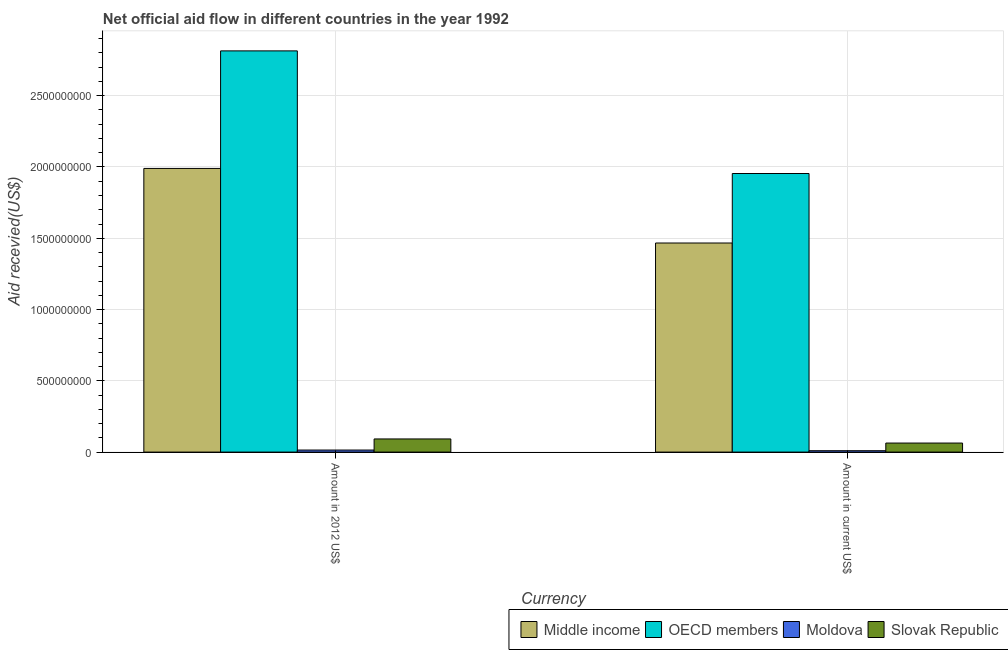Are the number of bars on each tick of the X-axis equal?
Offer a very short reply. Yes. How many bars are there on the 2nd tick from the right?
Provide a short and direct response. 4. What is the label of the 2nd group of bars from the left?
Provide a short and direct response. Amount in current US$. What is the amount of aid received(expressed in 2012 us$) in Middle income?
Make the answer very short. 1.99e+09. Across all countries, what is the maximum amount of aid received(expressed in 2012 us$)?
Provide a succinct answer. 2.81e+09. Across all countries, what is the minimum amount of aid received(expressed in us$)?
Provide a succinct answer. 9.70e+06. In which country was the amount of aid received(expressed in us$) maximum?
Your answer should be compact. OECD members. In which country was the amount of aid received(expressed in us$) minimum?
Give a very brief answer. Moldova. What is the total amount of aid received(expressed in us$) in the graph?
Your answer should be very brief. 3.49e+09. What is the difference between the amount of aid received(expressed in 2012 us$) in Middle income and that in Slovak Republic?
Provide a short and direct response. 1.90e+09. What is the difference between the amount of aid received(expressed in us$) in Slovak Republic and the amount of aid received(expressed in 2012 us$) in Middle income?
Offer a terse response. -1.93e+09. What is the average amount of aid received(expressed in 2012 us$) per country?
Offer a terse response. 1.23e+09. What is the difference between the amount of aid received(expressed in us$) and amount of aid received(expressed in 2012 us$) in Moldova?
Ensure brevity in your answer.  -4.72e+06. In how many countries, is the amount of aid received(expressed in 2012 us$) greater than 2600000000 US$?
Keep it short and to the point. 1. What is the ratio of the amount of aid received(expressed in 2012 us$) in Slovak Republic to that in Moldova?
Offer a very short reply. 6.4. Is the amount of aid received(expressed in us$) in OECD members less than that in Moldova?
Provide a succinct answer. No. What does the 2nd bar from the right in Amount in 2012 US$ represents?
Ensure brevity in your answer.  Moldova. How many bars are there?
Provide a short and direct response. 8. Are all the bars in the graph horizontal?
Your answer should be very brief. No. Are the values on the major ticks of Y-axis written in scientific E-notation?
Offer a terse response. No. Does the graph contain any zero values?
Your answer should be very brief. No. Does the graph contain grids?
Keep it short and to the point. Yes. Where does the legend appear in the graph?
Offer a terse response. Bottom right. How many legend labels are there?
Your answer should be compact. 4. What is the title of the graph?
Ensure brevity in your answer.  Net official aid flow in different countries in the year 1992. What is the label or title of the X-axis?
Provide a short and direct response. Currency. What is the label or title of the Y-axis?
Provide a short and direct response. Aid recevied(US$). What is the Aid recevied(US$) in Middle income in Amount in 2012 US$?
Offer a very short reply. 1.99e+09. What is the Aid recevied(US$) of OECD members in Amount in 2012 US$?
Your response must be concise. 2.81e+09. What is the Aid recevied(US$) of Moldova in Amount in 2012 US$?
Keep it short and to the point. 1.44e+07. What is the Aid recevied(US$) in Slovak Republic in Amount in 2012 US$?
Offer a terse response. 9.22e+07. What is the Aid recevied(US$) of Middle income in Amount in current US$?
Your response must be concise. 1.47e+09. What is the Aid recevied(US$) in OECD members in Amount in current US$?
Your response must be concise. 1.95e+09. What is the Aid recevied(US$) in Moldova in Amount in current US$?
Make the answer very short. 9.70e+06. What is the Aid recevied(US$) in Slovak Republic in Amount in current US$?
Offer a terse response. 6.34e+07. Across all Currency, what is the maximum Aid recevied(US$) in Middle income?
Give a very brief answer. 1.99e+09. Across all Currency, what is the maximum Aid recevied(US$) in OECD members?
Offer a very short reply. 2.81e+09. Across all Currency, what is the maximum Aid recevied(US$) in Moldova?
Provide a succinct answer. 1.44e+07. Across all Currency, what is the maximum Aid recevied(US$) in Slovak Republic?
Keep it short and to the point. 9.22e+07. Across all Currency, what is the minimum Aid recevied(US$) of Middle income?
Offer a very short reply. 1.47e+09. Across all Currency, what is the minimum Aid recevied(US$) of OECD members?
Provide a succinct answer. 1.95e+09. Across all Currency, what is the minimum Aid recevied(US$) in Moldova?
Provide a short and direct response. 9.70e+06. Across all Currency, what is the minimum Aid recevied(US$) of Slovak Republic?
Provide a succinct answer. 6.34e+07. What is the total Aid recevied(US$) in Middle income in the graph?
Ensure brevity in your answer.  3.46e+09. What is the total Aid recevied(US$) of OECD members in the graph?
Offer a very short reply. 4.77e+09. What is the total Aid recevied(US$) of Moldova in the graph?
Your answer should be compact. 2.41e+07. What is the total Aid recevied(US$) of Slovak Republic in the graph?
Offer a terse response. 1.56e+08. What is the difference between the Aid recevied(US$) in Middle income in Amount in 2012 US$ and that in Amount in current US$?
Offer a terse response. 5.23e+08. What is the difference between the Aid recevied(US$) of OECD members in Amount in 2012 US$ and that in Amount in current US$?
Give a very brief answer. 8.60e+08. What is the difference between the Aid recevied(US$) in Moldova in Amount in 2012 US$ and that in Amount in current US$?
Ensure brevity in your answer.  4.72e+06. What is the difference between the Aid recevied(US$) in Slovak Republic in Amount in 2012 US$ and that in Amount in current US$?
Provide a succinct answer. 2.89e+07. What is the difference between the Aid recevied(US$) of Middle income in Amount in 2012 US$ and the Aid recevied(US$) of OECD members in Amount in current US$?
Offer a very short reply. 3.56e+07. What is the difference between the Aid recevied(US$) of Middle income in Amount in 2012 US$ and the Aid recevied(US$) of Moldova in Amount in current US$?
Ensure brevity in your answer.  1.98e+09. What is the difference between the Aid recevied(US$) in Middle income in Amount in 2012 US$ and the Aid recevied(US$) in Slovak Republic in Amount in current US$?
Your answer should be very brief. 1.93e+09. What is the difference between the Aid recevied(US$) of OECD members in Amount in 2012 US$ and the Aid recevied(US$) of Moldova in Amount in current US$?
Make the answer very short. 2.80e+09. What is the difference between the Aid recevied(US$) in OECD members in Amount in 2012 US$ and the Aid recevied(US$) in Slovak Republic in Amount in current US$?
Provide a succinct answer. 2.75e+09. What is the difference between the Aid recevied(US$) in Moldova in Amount in 2012 US$ and the Aid recevied(US$) in Slovak Republic in Amount in current US$?
Your answer should be very brief. -4.89e+07. What is the average Aid recevied(US$) in Middle income per Currency?
Keep it short and to the point. 1.73e+09. What is the average Aid recevied(US$) of OECD members per Currency?
Provide a succinct answer. 2.38e+09. What is the average Aid recevied(US$) of Moldova per Currency?
Provide a short and direct response. 1.21e+07. What is the average Aid recevied(US$) in Slovak Republic per Currency?
Keep it short and to the point. 7.78e+07. What is the difference between the Aid recevied(US$) in Middle income and Aid recevied(US$) in OECD members in Amount in 2012 US$?
Give a very brief answer. -8.25e+08. What is the difference between the Aid recevied(US$) in Middle income and Aid recevied(US$) in Moldova in Amount in 2012 US$?
Your response must be concise. 1.98e+09. What is the difference between the Aid recevied(US$) in Middle income and Aid recevied(US$) in Slovak Republic in Amount in 2012 US$?
Your answer should be compact. 1.90e+09. What is the difference between the Aid recevied(US$) of OECD members and Aid recevied(US$) of Moldova in Amount in 2012 US$?
Your response must be concise. 2.80e+09. What is the difference between the Aid recevied(US$) of OECD members and Aid recevied(US$) of Slovak Republic in Amount in 2012 US$?
Your response must be concise. 2.72e+09. What is the difference between the Aid recevied(US$) of Moldova and Aid recevied(US$) of Slovak Republic in Amount in 2012 US$?
Make the answer very short. -7.78e+07. What is the difference between the Aid recevied(US$) in Middle income and Aid recevied(US$) in OECD members in Amount in current US$?
Your answer should be very brief. -4.88e+08. What is the difference between the Aid recevied(US$) in Middle income and Aid recevied(US$) in Moldova in Amount in current US$?
Offer a terse response. 1.46e+09. What is the difference between the Aid recevied(US$) of Middle income and Aid recevied(US$) of Slovak Republic in Amount in current US$?
Make the answer very short. 1.40e+09. What is the difference between the Aid recevied(US$) in OECD members and Aid recevied(US$) in Moldova in Amount in current US$?
Give a very brief answer. 1.94e+09. What is the difference between the Aid recevied(US$) in OECD members and Aid recevied(US$) in Slovak Republic in Amount in current US$?
Keep it short and to the point. 1.89e+09. What is the difference between the Aid recevied(US$) in Moldova and Aid recevied(US$) in Slovak Republic in Amount in current US$?
Make the answer very short. -5.37e+07. What is the ratio of the Aid recevied(US$) in Middle income in Amount in 2012 US$ to that in Amount in current US$?
Your answer should be very brief. 1.36. What is the ratio of the Aid recevied(US$) in OECD members in Amount in 2012 US$ to that in Amount in current US$?
Offer a terse response. 1.44. What is the ratio of the Aid recevied(US$) in Moldova in Amount in 2012 US$ to that in Amount in current US$?
Provide a short and direct response. 1.49. What is the ratio of the Aid recevied(US$) of Slovak Republic in Amount in 2012 US$ to that in Amount in current US$?
Your response must be concise. 1.46. What is the difference between the highest and the second highest Aid recevied(US$) in Middle income?
Provide a short and direct response. 5.23e+08. What is the difference between the highest and the second highest Aid recevied(US$) of OECD members?
Give a very brief answer. 8.60e+08. What is the difference between the highest and the second highest Aid recevied(US$) in Moldova?
Keep it short and to the point. 4.72e+06. What is the difference between the highest and the second highest Aid recevied(US$) of Slovak Republic?
Provide a succinct answer. 2.89e+07. What is the difference between the highest and the lowest Aid recevied(US$) in Middle income?
Offer a very short reply. 5.23e+08. What is the difference between the highest and the lowest Aid recevied(US$) in OECD members?
Your answer should be compact. 8.60e+08. What is the difference between the highest and the lowest Aid recevied(US$) of Moldova?
Keep it short and to the point. 4.72e+06. What is the difference between the highest and the lowest Aid recevied(US$) of Slovak Republic?
Keep it short and to the point. 2.89e+07. 